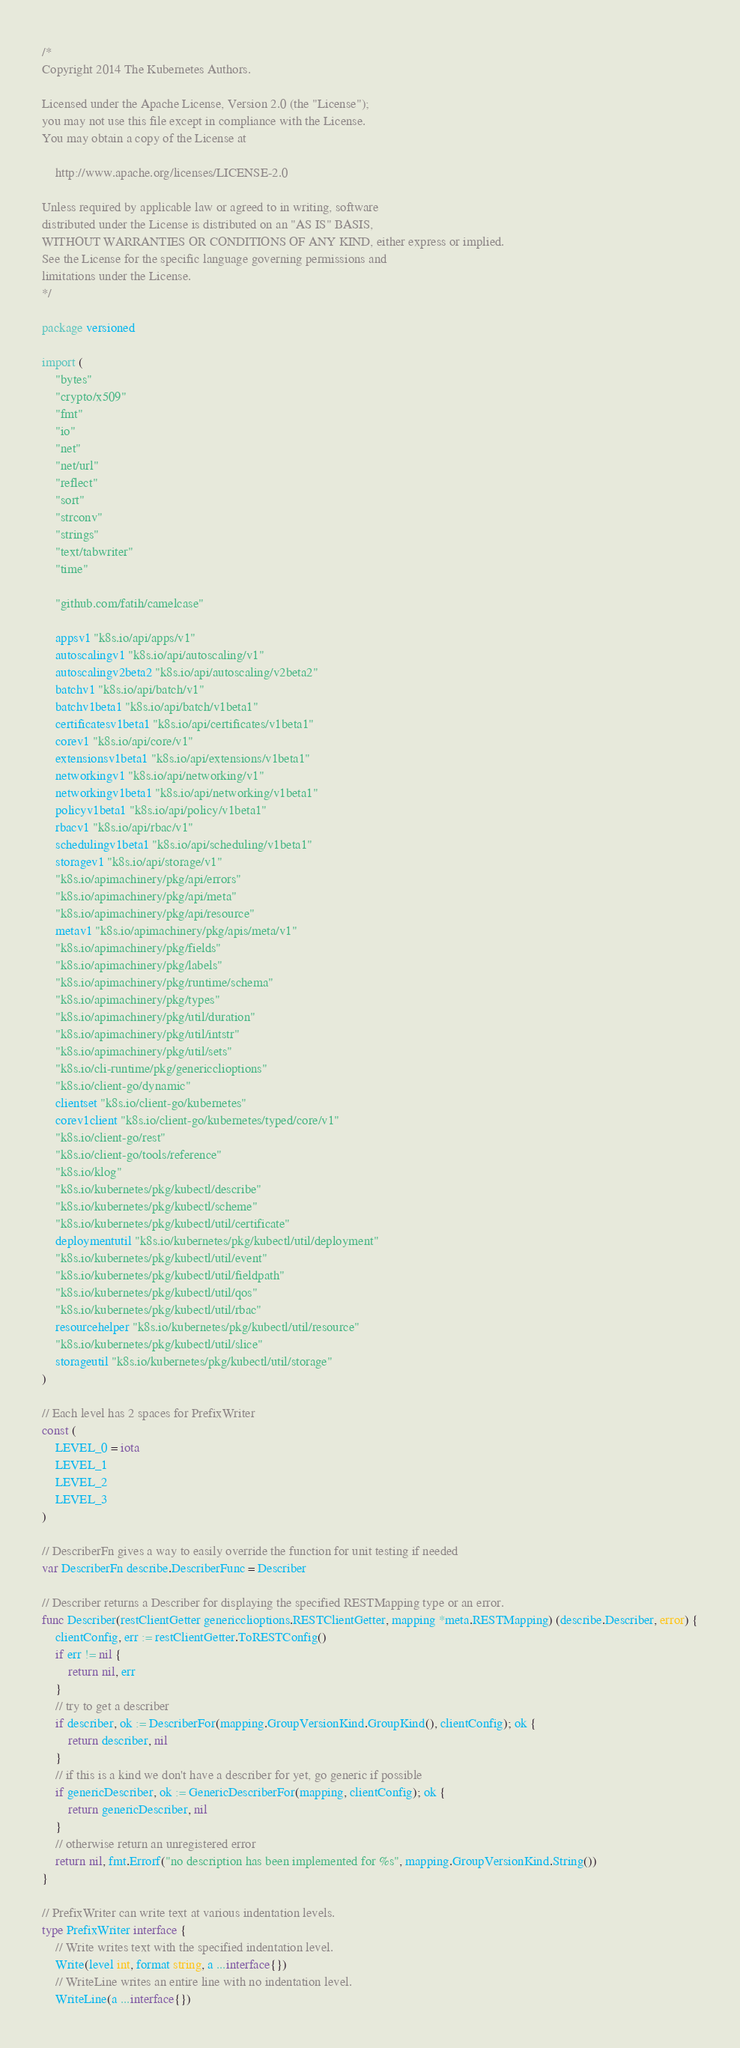Convert code to text. <code><loc_0><loc_0><loc_500><loc_500><_Go_>/*
Copyright 2014 The Kubernetes Authors.

Licensed under the Apache License, Version 2.0 (the "License");
you may not use this file except in compliance with the License.
You may obtain a copy of the License at

    http://www.apache.org/licenses/LICENSE-2.0

Unless required by applicable law or agreed to in writing, software
distributed under the License is distributed on an "AS IS" BASIS,
WITHOUT WARRANTIES OR CONDITIONS OF ANY KIND, either express or implied.
See the License for the specific language governing permissions and
limitations under the License.
*/

package versioned

import (
	"bytes"
	"crypto/x509"
	"fmt"
	"io"
	"net"
	"net/url"
	"reflect"
	"sort"
	"strconv"
	"strings"
	"text/tabwriter"
	"time"

	"github.com/fatih/camelcase"

	appsv1 "k8s.io/api/apps/v1"
	autoscalingv1 "k8s.io/api/autoscaling/v1"
	autoscalingv2beta2 "k8s.io/api/autoscaling/v2beta2"
	batchv1 "k8s.io/api/batch/v1"
	batchv1beta1 "k8s.io/api/batch/v1beta1"
	certificatesv1beta1 "k8s.io/api/certificates/v1beta1"
	corev1 "k8s.io/api/core/v1"
	extensionsv1beta1 "k8s.io/api/extensions/v1beta1"
	networkingv1 "k8s.io/api/networking/v1"
	networkingv1beta1 "k8s.io/api/networking/v1beta1"
	policyv1beta1 "k8s.io/api/policy/v1beta1"
	rbacv1 "k8s.io/api/rbac/v1"
	schedulingv1beta1 "k8s.io/api/scheduling/v1beta1"
	storagev1 "k8s.io/api/storage/v1"
	"k8s.io/apimachinery/pkg/api/errors"
	"k8s.io/apimachinery/pkg/api/meta"
	"k8s.io/apimachinery/pkg/api/resource"
	metav1 "k8s.io/apimachinery/pkg/apis/meta/v1"
	"k8s.io/apimachinery/pkg/fields"
	"k8s.io/apimachinery/pkg/labels"
	"k8s.io/apimachinery/pkg/runtime/schema"
	"k8s.io/apimachinery/pkg/types"
	"k8s.io/apimachinery/pkg/util/duration"
	"k8s.io/apimachinery/pkg/util/intstr"
	"k8s.io/apimachinery/pkg/util/sets"
	"k8s.io/cli-runtime/pkg/genericclioptions"
	"k8s.io/client-go/dynamic"
	clientset "k8s.io/client-go/kubernetes"
	corev1client "k8s.io/client-go/kubernetes/typed/core/v1"
	"k8s.io/client-go/rest"
	"k8s.io/client-go/tools/reference"
	"k8s.io/klog"
	"k8s.io/kubernetes/pkg/kubectl/describe"
	"k8s.io/kubernetes/pkg/kubectl/scheme"
	"k8s.io/kubernetes/pkg/kubectl/util/certificate"
	deploymentutil "k8s.io/kubernetes/pkg/kubectl/util/deployment"
	"k8s.io/kubernetes/pkg/kubectl/util/event"
	"k8s.io/kubernetes/pkg/kubectl/util/fieldpath"
	"k8s.io/kubernetes/pkg/kubectl/util/qos"
	"k8s.io/kubernetes/pkg/kubectl/util/rbac"
	resourcehelper "k8s.io/kubernetes/pkg/kubectl/util/resource"
	"k8s.io/kubernetes/pkg/kubectl/util/slice"
	storageutil "k8s.io/kubernetes/pkg/kubectl/util/storage"
)

// Each level has 2 spaces for PrefixWriter
const (
	LEVEL_0 = iota
	LEVEL_1
	LEVEL_2
	LEVEL_3
)

// DescriberFn gives a way to easily override the function for unit testing if needed
var DescriberFn describe.DescriberFunc = Describer

// Describer returns a Describer for displaying the specified RESTMapping type or an error.
func Describer(restClientGetter genericclioptions.RESTClientGetter, mapping *meta.RESTMapping) (describe.Describer, error) {
	clientConfig, err := restClientGetter.ToRESTConfig()
	if err != nil {
		return nil, err
	}
	// try to get a describer
	if describer, ok := DescriberFor(mapping.GroupVersionKind.GroupKind(), clientConfig); ok {
		return describer, nil
	}
	// if this is a kind we don't have a describer for yet, go generic if possible
	if genericDescriber, ok := GenericDescriberFor(mapping, clientConfig); ok {
		return genericDescriber, nil
	}
	// otherwise return an unregistered error
	return nil, fmt.Errorf("no description has been implemented for %s", mapping.GroupVersionKind.String())
}

// PrefixWriter can write text at various indentation levels.
type PrefixWriter interface {
	// Write writes text with the specified indentation level.
	Write(level int, format string, a ...interface{})
	// WriteLine writes an entire line with no indentation level.
	WriteLine(a ...interface{})</code> 